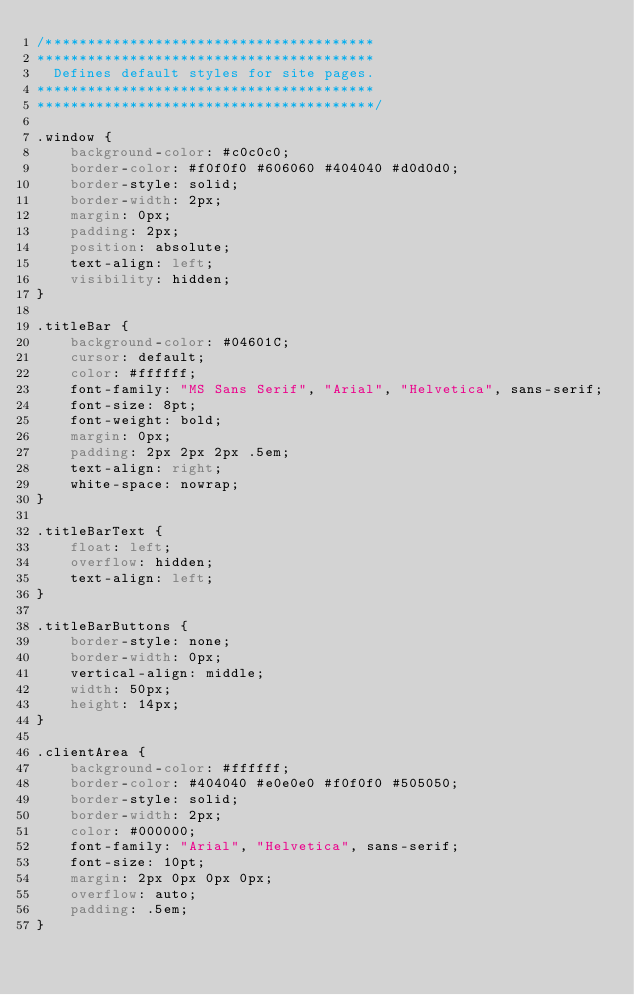<code> <loc_0><loc_0><loc_500><loc_500><_CSS_>/***************************************
**************************************** 
  Defines default styles for site pages.                                      
****************************************
****************************************/

.window {
	background-color: #c0c0c0;
	border-color: #f0f0f0 #606060 #404040 #d0d0d0;
	border-style: solid;
	border-width: 2px;
	margin: 0px;
	padding: 2px;
	position: absolute;
	text-align: left;
	visibility: hidden;
}

.titleBar {
	background-color: #04601C;
	cursor: default;
	color: #ffffff;
	font-family: "MS Sans Serif", "Arial", "Helvetica", sans-serif;
	font-size: 8pt;
	font-weight: bold;
	margin: 0px;
	padding: 2px 2px 2px .5em;
	text-align: right;
	white-space: nowrap;
}

.titleBarText {
	float: left;
	overflow: hidden;
	text-align: left;
}

.titleBarButtons {
	border-style: none;
	border-width: 0px;
	vertical-align: middle;
	width: 50px;
	height: 14px;
}

.clientArea {
	background-color: #ffffff;
	border-color: #404040 #e0e0e0 #f0f0f0 #505050;
	border-style: solid;
	border-width: 2px;
	color: #000000;
	font-family: "Arial", "Helvetica", sans-serif;
	font-size: 10pt;
	margin: 2px 0px 0px 0px;
	overflow: auto;
	padding: .5em;
}</code> 